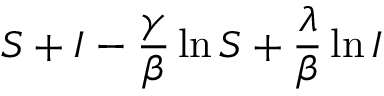Convert formula to latex. <formula><loc_0><loc_0><loc_500><loc_500>S + I - \frac { \gamma } { \beta } \ln S + \frac { \lambda } { \beta } \ln I</formula> 